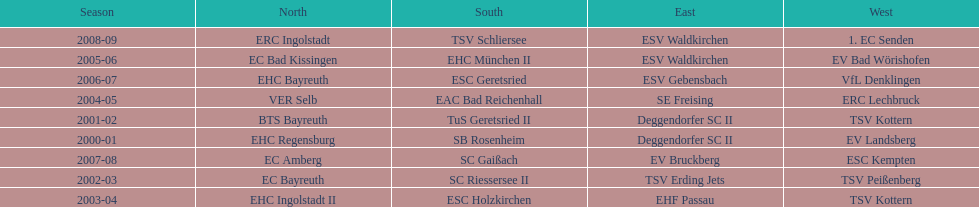Who won the south after esc geretsried did during the 2006-07 season? SC Gaißach. 